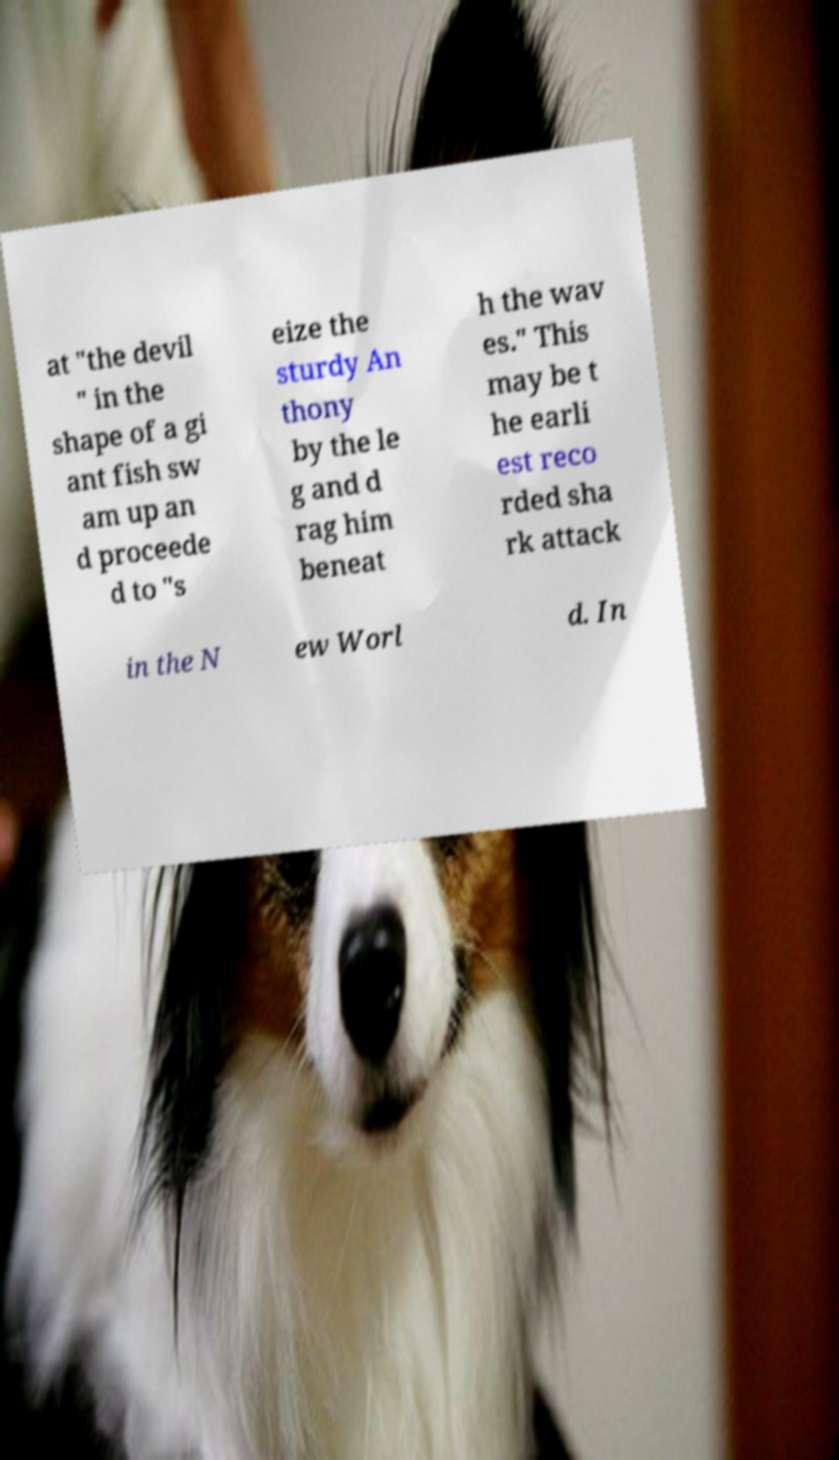Could you extract and type out the text from this image? at "the devil " in the shape of a gi ant fish sw am up an d proceede d to "s eize the sturdy An thony by the le g and d rag him beneat h the wav es." This may be t he earli est reco rded sha rk attack in the N ew Worl d. In 